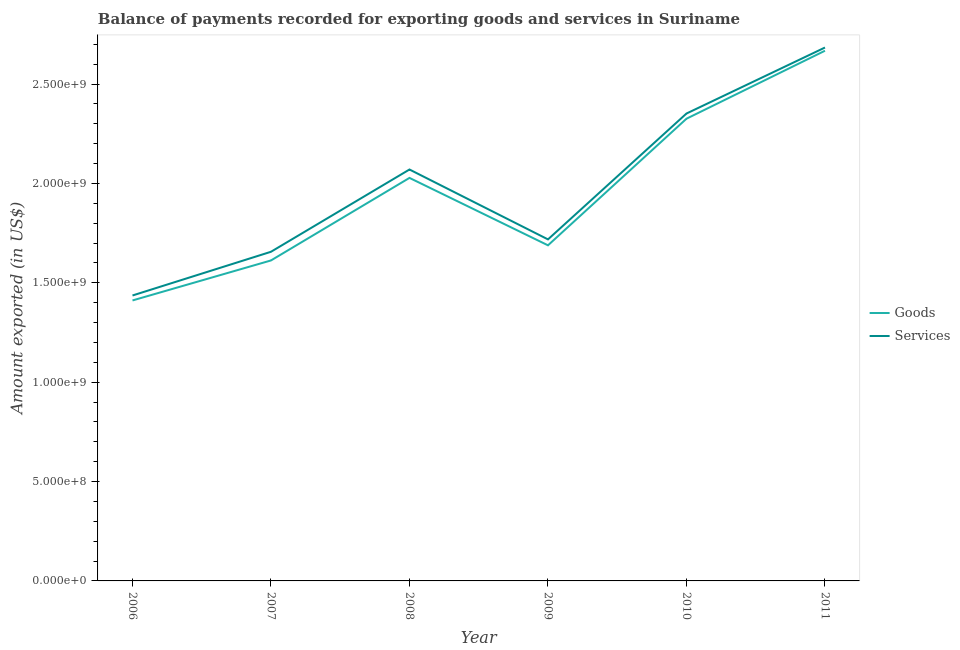Does the line corresponding to amount of goods exported intersect with the line corresponding to amount of services exported?
Your answer should be compact. No. Is the number of lines equal to the number of legend labels?
Your answer should be compact. Yes. What is the amount of goods exported in 2011?
Offer a very short reply. 2.67e+09. Across all years, what is the maximum amount of goods exported?
Make the answer very short. 2.67e+09. Across all years, what is the minimum amount of goods exported?
Offer a very short reply. 1.41e+09. In which year was the amount of goods exported maximum?
Provide a succinct answer. 2011. What is the total amount of goods exported in the graph?
Give a very brief answer. 1.17e+1. What is the difference between the amount of services exported in 2007 and that in 2009?
Ensure brevity in your answer.  -6.23e+07. What is the difference between the amount of goods exported in 2007 and the amount of services exported in 2008?
Ensure brevity in your answer.  -4.58e+08. What is the average amount of goods exported per year?
Make the answer very short. 1.96e+09. In the year 2006, what is the difference between the amount of services exported and amount of goods exported?
Your response must be concise. 2.50e+07. In how many years, is the amount of services exported greater than 700000000 US$?
Provide a succinct answer. 6. What is the ratio of the amount of services exported in 2006 to that in 2011?
Provide a succinct answer. 0.54. Is the amount of goods exported in 2006 less than that in 2011?
Offer a terse response. Yes. Is the difference between the amount of services exported in 2008 and 2009 greater than the difference between the amount of goods exported in 2008 and 2009?
Make the answer very short. Yes. What is the difference between the highest and the second highest amount of services exported?
Provide a short and direct response. 3.32e+08. What is the difference between the highest and the lowest amount of services exported?
Make the answer very short. 1.25e+09. Is the amount of services exported strictly greater than the amount of goods exported over the years?
Provide a succinct answer. Yes. How many lines are there?
Your response must be concise. 2. How many years are there in the graph?
Offer a very short reply. 6. Are the values on the major ticks of Y-axis written in scientific E-notation?
Your answer should be compact. Yes. Does the graph contain grids?
Make the answer very short. No. Where does the legend appear in the graph?
Your answer should be very brief. Center right. How many legend labels are there?
Ensure brevity in your answer.  2. How are the legend labels stacked?
Make the answer very short. Vertical. What is the title of the graph?
Your answer should be very brief. Balance of payments recorded for exporting goods and services in Suriname. What is the label or title of the X-axis?
Provide a short and direct response. Year. What is the label or title of the Y-axis?
Your response must be concise. Amount exported (in US$). What is the Amount exported (in US$) of Goods in 2006?
Ensure brevity in your answer.  1.41e+09. What is the Amount exported (in US$) of Services in 2006?
Keep it short and to the point. 1.44e+09. What is the Amount exported (in US$) in Goods in 2007?
Keep it short and to the point. 1.61e+09. What is the Amount exported (in US$) in Services in 2007?
Keep it short and to the point. 1.66e+09. What is the Amount exported (in US$) in Goods in 2008?
Ensure brevity in your answer.  2.03e+09. What is the Amount exported (in US$) of Services in 2008?
Ensure brevity in your answer.  2.07e+09. What is the Amount exported (in US$) of Goods in 2009?
Ensure brevity in your answer.  1.69e+09. What is the Amount exported (in US$) of Services in 2009?
Keep it short and to the point. 1.72e+09. What is the Amount exported (in US$) in Goods in 2010?
Provide a succinct answer. 2.33e+09. What is the Amount exported (in US$) of Services in 2010?
Provide a succinct answer. 2.35e+09. What is the Amount exported (in US$) of Goods in 2011?
Offer a terse response. 2.67e+09. What is the Amount exported (in US$) in Services in 2011?
Ensure brevity in your answer.  2.68e+09. Across all years, what is the maximum Amount exported (in US$) in Goods?
Your answer should be very brief. 2.67e+09. Across all years, what is the maximum Amount exported (in US$) in Services?
Your answer should be very brief. 2.68e+09. Across all years, what is the minimum Amount exported (in US$) of Goods?
Give a very brief answer. 1.41e+09. Across all years, what is the minimum Amount exported (in US$) of Services?
Provide a short and direct response. 1.44e+09. What is the total Amount exported (in US$) in Goods in the graph?
Provide a succinct answer. 1.17e+1. What is the total Amount exported (in US$) of Services in the graph?
Make the answer very short. 1.19e+1. What is the difference between the Amount exported (in US$) of Goods in 2006 and that in 2007?
Offer a very short reply. -2.01e+08. What is the difference between the Amount exported (in US$) of Services in 2006 and that in 2007?
Provide a succinct answer. -2.20e+08. What is the difference between the Amount exported (in US$) of Goods in 2006 and that in 2008?
Keep it short and to the point. -6.17e+08. What is the difference between the Amount exported (in US$) of Services in 2006 and that in 2008?
Offer a very short reply. -6.34e+08. What is the difference between the Amount exported (in US$) of Goods in 2006 and that in 2009?
Your response must be concise. -2.77e+08. What is the difference between the Amount exported (in US$) in Services in 2006 and that in 2009?
Ensure brevity in your answer.  -2.82e+08. What is the difference between the Amount exported (in US$) of Goods in 2006 and that in 2010?
Give a very brief answer. -9.14e+08. What is the difference between the Amount exported (in US$) in Services in 2006 and that in 2010?
Offer a very short reply. -9.16e+08. What is the difference between the Amount exported (in US$) of Goods in 2006 and that in 2011?
Your answer should be compact. -1.26e+09. What is the difference between the Amount exported (in US$) of Services in 2006 and that in 2011?
Your response must be concise. -1.25e+09. What is the difference between the Amount exported (in US$) in Goods in 2007 and that in 2008?
Your answer should be very brief. -4.15e+08. What is the difference between the Amount exported (in US$) of Services in 2007 and that in 2008?
Keep it short and to the point. -4.14e+08. What is the difference between the Amount exported (in US$) in Goods in 2007 and that in 2009?
Offer a terse response. -7.61e+07. What is the difference between the Amount exported (in US$) in Services in 2007 and that in 2009?
Your answer should be very brief. -6.23e+07. What is the difference between the Amount exported (in US$) in Goods in 2007 and that in 2010?
Provide a short and direct response. -7.13e+08. What is the difference between the Amount exported (in US$) of Services in 2007 and that in 2010?
Your answer should be very brief. -6.96e+08. What is the difference between the Amount exported (in US$) of Goods in 2007 and that in 2011?
Make the answer very short. -1.06e+09. What is the difference between the Amount exported (in US$) in Services in 2007 and that in 2011?
Your answer should be very brief. -1.03e+09. What is the difference between the Amount exported (in US$) in Goods in 2008 and that in 2009?
Offer a terse response. 3.39e+08. What is the difference between the Amount exported (in US$) of Services in 2008 and that in 2009?
Your response must be concise. 3.52e+08. What is the difference between the Amount exported (in US$) of Goods in 2008 and that in 2010?
Provide a succinct answer. -2.98e+08. What is the difference between the Amount exported (in US$) in Services in 2008 and that in 2010?
Your answer should be compact. -2.82e+08. What is the difference between the Amount exported (in US$) of Goods in 2008 and that in 2011?
Give a very brief answer. -6.40e+08. What is the difference between the Amount exported (in US$) of Services in 2008 and that in 2011?
Make the answer very short. -6.14e+08. What is the difference between the Amount exported (in US$) of Goods in 2009 and that in 2010?
Provide a short and direct response. -6.37e+08. What is the difference between the Amount exported (in US$) in Services in 2009 and that in 2010?
Offer a very short reply. -6.33e+08. What is the difference between the Amount exported (in US$) in Goods in 2009 and that in 2011?
Give a very brief answer. -9.79e+08. What is the difference between the Amount exported (in US$) of Services in 2009 and that in 2011?
Your answer should be very brief. -9.65e+08. What is the difference between the Amount exported (in US$) in Goods in 2010 and that in 2011?
Ensure brevity in your answer.  -3.42e+08. What is the difference between the Amount exported (in US$) of Services in 2010 and that in 2011?
Your response must be concise. -3.32e+08. What is the difference between the Amount exported (in US$) in Goods in 2006 and the Amount exported (in US$) in Services in 2007?
Provide a short and direct response. -2.45e+08. What is the difference between the Amount exported (in US$) of Goods in 2006 and the Amount exported (in US$) of Services in 2008?
Make the answer very short. -6.59e+08. What is the difference between the Amount exported (in US$) in Goods in 2006 and the Amount exported (in US$) in Services in 2009?
Your answer should be very brief. -3.07e+08. What is the difference between the Amount exported (in US$) of Goods in 2006 and the Amount exported (in US$) of Services in 2010?
Provide a short and direct response. -9.40e+08. What is the difference between the Amount exported (in US$) of Goods in 2006 and the Amount exported (in US$) of Services in 2011?
Offer a very short reply. -1.27e+09. What is the difference between the Amount exported (in US$) in Goods in 2007 and the Amount exported (in US$) in Services in 2008?
Keep it short and to the point. -4.58e+08. What is the difference between the Amount exported (in US$) of Goods in 2007 and the Amount exported (in US$) of Services in 2009?
Provide a succinct answer. -1.06e+08. What is the difference between the Amount exported (in US$) of Goods in 2007 and the Amount exported (in US$) of Services in 2010?
Make the answer very short. -7.39e+08. What is the difference between the Amount exported (in US$) of Goods in 2007 and the Amount exported (in US$) of Services in 2011?
Offer a terse response. -1.07e+09. What is the difference between the Amount exported (in US$) of Goods in 2008 and the Amount exported (in US$) of Services in 2009?
Offer a terse response. 3.09e+08. What is the difference between the Amount exported (in US$) in Goods in 2008 and the Amount exported (in US$) in Services in 2010?
Give a very brief answer. -3.24e+08. What is the difference between the Amount exported (in US$) of Goods in 2008 and the Amount exported (in US$) of Services in 2011?
Keep it short and to the point. -6.56e+08. What is the difference between the Amount exported (in US$) of Goods in 2009 and the Amount exported (in US$) of Services in 2010?
Offer a very short reply. -6.63e+08. What is the difference between the Amount exported (in US$) of Goods in 2009 and the Amount exported (in US$) of Services in 2011?
Ensure brevity in your answer.  -9.95e+08. What is the difference between the Amount exported (in US$) of Goods in 2010 and the Amount exported (in US$) of Services in 2011?
Keep it short and to the point. -3.58e+08. What is the average Amount exported (in US$) in Goods per year?
Your answer should be compact. 1.96e+09. What is the average Amount exported (in US$) of Services per year?
Your response must be concise. 1.99e+09. In the year 2006, what is the difference between the Amount exported (in US$) in Goods and Amount exported (in US$) in Services?
Offer a very short reply. -2.50e+07. In the year 2007, what is the difference between the Amount exported (in US$) of Goods and Amount exported (in US$) of Services?
Make the answer very short. -4.36e+07. In the year 2008, what is the difference between the Amount exported (in US$) of Goods and Amount exported (in US$) of Services?
Provide a short and direct response. -4.22e+07. In the year 2009, what is the difference between the Amount exported (in US$) of Goods and Amount exported (in US$) of Services?
Your response must be concise. -2.98e+07. In the year 2010, what is the difference between the Amount exported (in US$) of Goods and Amount exported (in US$) of Services?
Keep it short and to the point. -2.61e+07. In the year 2011, what is the difference between the Amount exported (in US$) of Goods and Amount exported (in US$) of Services?
Provide a succinct answer. -1.62e+07. What is the ratio of the Amount exported (in US$) of Goods in 2006 to that in 2007?
Provide a succinct answer. 0.88. What is the ratio of the Amount exported (in US$) in Services in 2006 to that in 2007?
Your answer should be very brief. 0.87. What is the ratio of the Amount exported (in US$) in Goods in 2006 to that in 2008?
Ensure brevity in your answer.  0.7. What is the ratio of the Amount exported (in US$) of Services in 2006 to that in 2008?
Provide a succinct answer. 0.69. What is the ratio of the Amount exported (in US$) in Goods in 2006 to that in 2009?
Provide a succinct answer. 0.84. What is the ratio of the Amount exported (in US$) in Services in 2006 to that in 2009?
Make the answer very short. 0.84. What is the ratio of the Amount exported (in US$) of Goods in 2006 to that in 2010?
Your answer should be very brief. 0.61. What is the ratio of the Amount exported (in US$) of Services in 2006 to that in 2010?
Offer a very short reply. 0.61. What is the ratio of the Amount exported (in US$) in Goods in 2006 to that in 2011?
Your response must be concise. 0.53. What is the ratio of the Amount exported (in US$) in Services in 2006 to that in 2011?
Make the answer very short. 0.54. What is the ratio of the Amount exported (in US$) in Goods in 2007 to that in 2008?
Your answer should be very brief. 0.8. What is the ratio of the Amount exported (in US$) of Services in 2007 to that in 2008?
Your answer should be very brief. 0.8. What is the ratio of the Amount exported (in US$) of Goods in 2007 to that in 2009?
Keep it short and to the point. 0.95. What is the ratio of the Amount exported (in US$) in Services in 2007 to that in 2009?
Your response must be concise. 0.96. What is the ratio of the Amount exported (in US$) of Goods in 2007 to that in 2010?
Make the answer very short. 0.69. What is the ratio of the Amount exported (in US$) of Services in 2007 to that in 2010?
Provide a short and direct response. 0.7. What is the ratio of the Amount exported (in US$) in Goods in 2007 to that in 2011?
Your answer should be compact. 0.6. What is the ratio of the Amount exported (in US$) of Services in 2007 to that in 2011?
Make the answer very short. 0.62. What is the ratio of the Amount exported (in US$) in Goods in 2008 to that in 2009?
Make the answer very short. 1.2. What is the ratio of the Amount exported (in US$) in Services in 2008 to that in 2009?
Your answer should be compact. 1.2. What is the ratio of the Amount exported (in US$) in Goods in 2008 to that in 2010?
Provide a succinct answer. 0.87. What is the ratio of the Amount exported (in US$) in Services in 2008 to that in 2010?
Provide a succinct answer. 0.88. What is the ratio of the Amount exported (in US$) in Goods in 2008 to that in 2011?
Keep it short and to the point. 0.76. What is the ratio of the Amount exported (in US$) of Services in 2008 to that in 2011?
Provide a short and direct response. 0.77. What is the ratio of the Amount exported (in US$) of Goods in 2009 to that in 2010?
Offer a very short reply. 0.73. What is the ratio of the Amount exported (in US$) of Services in 2009 to that in 2010?
Give a very brief answer. 0.73. What is the ratio of the Amount exported (in US$) in Goods in 2009 to that in 2011?
Your answer should be compact. 0.63. What is the ratio of the Amount exported (in US$) of Services in 2009 to that in 2011?
Offer a terse response. 0.64. What is the ratio of the Amount exported (in US$) of Goods in 2010 to that in 2011?
Offer a terse response. 0.87. What is the ratio of the Amount exported (in US$) in Services in 2010 to that in 2011?
Ensure brevity in your answer.  0.88. What is the difference between the highest and the second highest Amount exported (in US$) in Goods?
Provide a short and direct response. 3.42e+08. What is the difference between the highest and the second highest Amount exported (in US$) in Services?
Offer a terse response. 3.32e+08. What is the difference between the highest and the lowest Amount exported (in US$) of Goods?
Make the answer very short. 1.26e+09. What is the difference between the highest and the lowest Amount exported (in US$) of Services?
Offer a very short reply. 1.25e+09. 